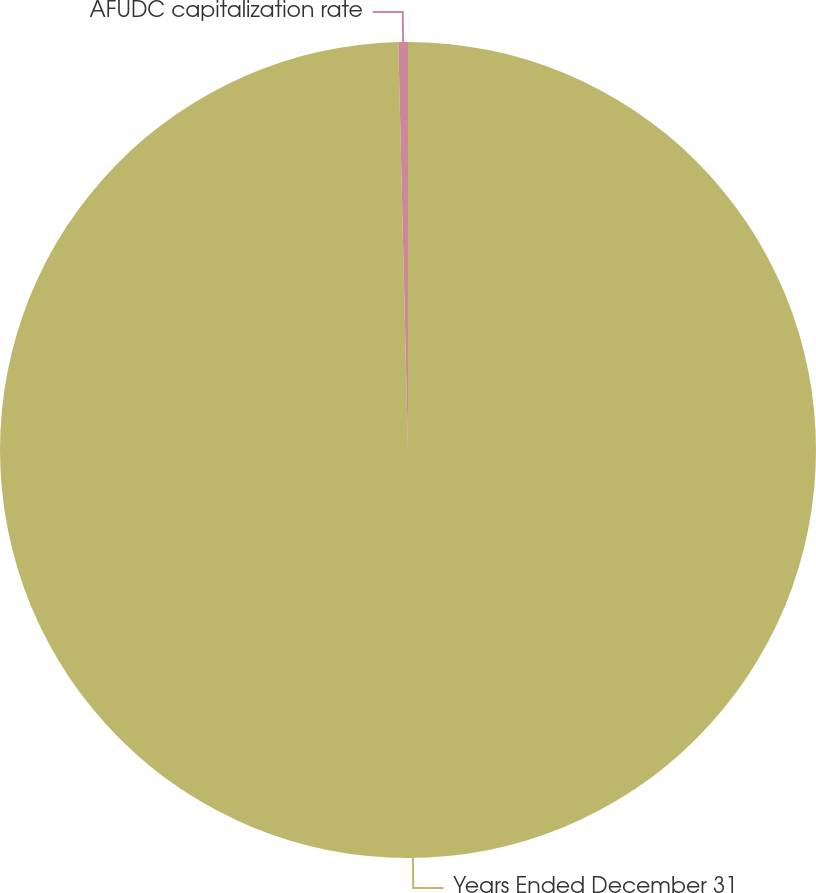Convert chart. <chart><loc_0><loc_0><loc_500><loc_500><pie_chart><fcel>Years Ended December 31<fcel>AFUDC capitalization rate<nl><fcel>99.62%<fcel>0.38%<nl></chart> 